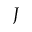<formula> <loc_0><loc_0><loc_500><loc_500>J</formula> 